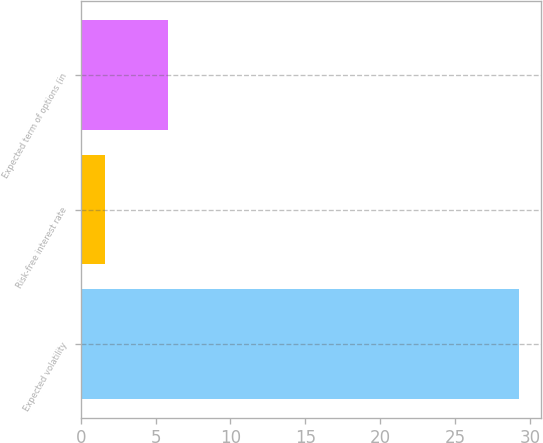Convert chart to OTSL. <chart><loc_0><loc_0><loc_500><loc_500><bar_chart><fcel>Expected volatility<fcel>Risk-free interest rate<fcel>Expected term of options (in<nl><fcel>29.28<fcel>1.63<fcel>5.82<nl></chart> 